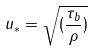Convert formula to latex. <formula><loc_0><loc_0><loc_500><loc_500>u _ { * } = \sqrt { ( \frac { \tau _ { b } } { \rho } ) }</formula> 